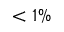<formula> <loc_0><loc_0><loc_500><loc_500>< 1 \%</formula> 